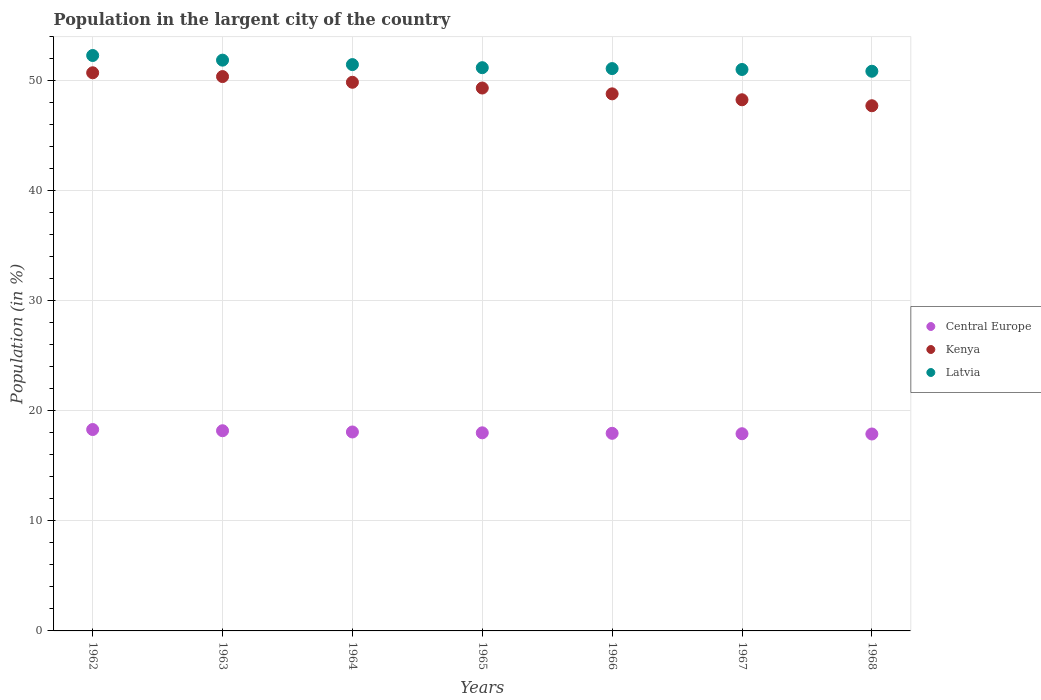Is the number of dotlines equal to the number of legend labels?
Provide a succinct answer. Yes. What is the percentage of population in the largent city in Latvia in 1965?
Provide a succinct answer. 51.19. Across all years, what is the maximum percentage of population in the largent city in Kenya?
Offer a terse response. 50.73. Across all years, what is the minimum percentage of population in the largent city in Central Europe?
Provide a short and direct response. 17.9. In which year was the percentage of population in the largent city in Latvia minimum?
Provide a succinct answer. 1968. What is the total percentage of population in the largent city in Latvia in the graph?
Give a very brief answer. 359.87. What is the difference between the percentage of population in the largent city in Kenya in 1965 and that in 1967?
Your answer should be compact. 1.07. What is the difference between the percentage of population in the largent city in Central Europe in 1962 and the percentage of population in the largent city in Kenya in 1963?
Your response must be concise. -32.08. What is the average percentage of population in the largent city in Latvia per year?
Make the answer very short. 51.41. In the year 1962, what is the difference between the percentage of population in the largent city in Latvia and percentage of population in the largent city in Kenya?
Your answer should be compact. 1.57. What is the ratio of the percentage of population in the largent city in Latvia in 1962 to that in 1964?
Keep it short and to the point. 1.02. Is the difference between the percentage of population in the largent city in Latvia in 1962 and 1963 greater than the difference between the percentage of population in the largent city in Kenya in 1962 and 1963?
Make the answer very short. Yes. What is the difference between the highest and the second highest percentage of population in the largent city in Central Europe?
Your answer should be very brief. 0.11. What is the difference between the highest and the lowest percentage of population in the largent city in Central Europe?
Provide a short and direct response. 0.41. In how many years, is the percentage of population in the largent city in Central Europe greater than the average percentage of population in the largent city in Central Europe taken over all years?
Your response must be concise. 3. Is it the case that in every year, the sum of the percentage of population in the largent city in Kenya and percentage of population in the largent city in Central Europe  is greater than the percentage of population in the largent city in Latvia?
Your answer should be very brief. Yes. Does the percentage of population in the largent city in Latvia monotonically increase over the years?
Offer a very short reply. No. Is the percentage of population in the largent city in Central Europe strictly less than the percentage of population in the largent city in Kenya over the years?
Ensure brevity in your answer.  Yes. How many years are there in the graph?
Provide a succinct answer. 7. Are the values on the major ticks of Y-axis written in scientific E-notation?
Provide a succinct answer. No. How are the legend labels stacked?
Give a very brief answer. Vertical. What is the title of the graph?
Ensure brevity in your answer.  Population in the largent city of the country. What is the Population (in %) of Central Europe in 1962?
Your answer should be compact. 18.31. What is the Population (in %) in Kenya in 1962?
Provide a succinct answer. 50.73. What is the Population (in %) in Latvia in 1962?
Ensure brevity in your answer.  52.3. What is the Population (in %) in Central Europe in 1963?
Ensure brevity in your answer.  18.2. What is the Population (in %) of Kenya in 1963?
Your answer should be very brief. 50.39. What is the Population (in %) of Latvia in 1963?
Your answer should be very brief. 51.88. What is the Population (in %) of Central Europe in 1964?
Offer a very short reply. 18.08. What is the Population (in %) in Kenya in 1964?
Keep it short and to the point. 49.87. What is the Population (in %) in Latvia in 1964?
Your answer should be very brief. 51.48. What is the Population (in %) of Central Europe in 1965?
Your answer should be very brief. 18.01. What is the Population (in %) in Kenya in 1965?
Your answer should be very brief. 49.35. What is the Population (in %) in Latvia in 1965?
Make the answer very short. 51.19. What is the Population (in %) in Central Europe in 1966?
Provide a short and direct response. 17.96. What is the Population (in %) in Kenya in 1966?
Ensure brevity in your answer.  48.82. What is the Population (in %) of Latvia in 1966?
Provide a succinct answer. 51.11. What is the Population (in %) of Central Europe in 1967?
Ensure brevity in your answer.  17.92. What is the Population (in %) in Kenya in 1967?
Your answer should be very brief. 48.28. What is the Population (in %) in Latvia in 1967?
Provide a short and direct response. 51.03. What is the Population (in %) in Central Europe in 1968?
Your answer should be compact. 17.9. What is the Population (in %) in Kenya in 1968?
Provide a short and direct response. 47.74. What is the Population (in %) of Latvia in 1968?
Your response must be concise. 50.87. Across all years, what is the maximum Population (in %) of Central Europe?
Your response must be concise. 18.31. Across all years, what is the maximum Population (in %) of Kenya?
Give a very brief answer. 50.73. Across all years, what is the maximum Population (in %) in Latvia?
Provide a short and direct response. 52.3. Across all years, what is the minimum Population (in %) of Central Europe?
Your response must be concise. 17.9. Across all years, what is the minimum Population (in %) in Kenya?
Offer a terse response. 47.74. Across all years, what is the minimum Population (in %) of Latvia?
Provide a succinct answer. 50.87. What is the total Population (in %) of Central Europe in the graph?
Offer a very short reply. 126.37. What is the total Population (in %) in Kenya in the graph?
Your answer should be compact. 345.16. What is the total Population (in %) in Latvia in the graph?
Give a very brief answer. 359.87. What is the difference between the Population (in %) of Central Europe in 1962 and that in 1963?
Keep it short and to the point. 0.11. What is the difference between the Population (in %) of Kenya in 1962 and that in 1963?
Give a very brief answer. 0.34. What is the difference between the Population (in %) in Latvia in 1962 and that in 1963?
Your response must be concise. 0.42. What is the difference between the Population (in %) of Central Europe in 1962 and that in 1964?
Offer a very short reply. 0.22. What is the difference between the Population (in %) in Kenya in 1962 and that in 1964?
Ensure brevity in your answer.  0.86. What is the difference between the Population (in %) in Latvia in 1962 and that in 1964?
Make the answer very short. 0.83. What is the difference between the Population (in %) in Central Europe in 1962 and that in 1965?
Your answer should be compact. 0.3. What is the difference between the Population (in %) in Kenya in 1962 and that in 1965?
Provide a short and direct response. 1.39. What is the difference between the Population (in %) in Latvia in 1962 and that in 1965?
Provide a succinct answer. 1.11. What is the difference between the Population (in %) of Central Europe in 1962 and that in 1966?
Make the answer very short. 0.34. What is the difference between the Population (in %) in Kenya in 1962 and that in 1966?
Offer a very short reply. 1.91. What is the difference between the Population (in %) of Latvia in 1962 and that in 1966?
Provide a succinct answer. 1.19. What is the difference between the Population (in %) of Central Europe in 1962 and that in 1967?
Your answer should be compact. 0.38. What is the difference between the Population (in %) in Kenya in 1962 and that in 1967?
Offer a terse response. 2.45. What is the difference between the Population (in %) of Latvia in 1962 and that in 1967?
Offer a terse response. 1.27. What is the difference between the Population (in %) of Central Europe in 1962 and that in 1968?
Your answer should be very brief. 0.41. What is the difference between the Population (in %) in Kenya in 1962 and that in 1968?
Offer a terse response. 3. What is the difference between the Population (in %) in Latvia in 1962 and that in 1968?
Make the answer very short. 1.43. What is the difference between the Population (in %) in Central Europe in 1963 and that in 1964?
Your answer should be compact. 0.11. What is the difference between the Population (in %) in Kenya in 1963 and that in 1964?
Keep it short and to the point. 0.52. What is the difference between the Population (in %) of Latvia in 1963 and that in 1964?
Provide a succinct answer. 0.4. What is the difference between the Population (in %) in Central Europe in 1963 and that in 1965?
Your answer should be very brief. 0.19. What is the difference between the Population (in %) in Kenya in 1963 and that in 1965?
Keep it short and to the point. 1.04. What is the difference between the Population (in %) in Latvia in 1963 and that in 1965?
Offer a terse response. 0.69. What is the difference between the Population (in %) in Central Europe in 1963 and that in 1966?
Your answer should be very brief. 0.23. What is the difference between the Population (in %) in Kenya in 1963 and that in 1966?
Your response must be concise. 1.57. What is the difference between the Population (in %) of Latvia in 1963 and that in 1966?
Provide a short and direct response. 0.77. What is the difference between the Population (in %) in Central Europe in 1963 and that in 1967?
Give a very brief answer. 0.27. What is the difference between the Population (in %) of Kenya in 1963 and that in 1967?
Offer a very short reply. 2.11. What is the difference between the Population (in %) in Latvia in 1963 and that in 1967?
Offer a terse response. 0.85. What is the difference between the Population (in %) of Central Europe in 1963 and that in 1968?
Keep it short and to the point. 0.3. What is the difference between the Population (in %) of Kenya in 1963 and that in 1968?
Offer a very short reply. 2.65. What is the difference between the Population (in %) in Latvia in 1963 and that in 1968?
Your answer should be compact. 1.01. What is the difference between the Population (in %) in Central Europe in 1964 and that in 1965?
Your answer should be compact. 0.08. What is the difference between the Population (in %) of Kenya in 1964 and that in 1965?
Your answer should be compact. 0.52. What is the difference between the Population (in %) in Latvia in 1964 and that in 1965?
Your answer should be compact. 0.28. What is the difference between the Population (in %) of Central Europe in 1964 and that in 1966?
Ensure brevity in your answer.  0.12. What is the difference between the Population (in %) of Kenya in 1964 and that in 1966?
Offer a terse response. 1.05. What is the difference between the Population (in %) in Latvia in 1964 and that in 1966?
Your answer should be very brief. 0.36. What is the difference between the Population (in %) of Central Europe in 1964 and that in 1967?
Offer a terse response. 0.16. What is the difference between the Population (in %) of Kenya in 1964 and that in 1967?
Keep it short and to the point. 1.59. What is the difference between the Population (in %) in Latvia in 1964 and that in 1967?
Offer a very short reply. 0.44. What is the difference between the Population (in %) in Central Europe in 1964 and that in 1968?
Your answer should be very brief. 0.18. What is the difference between the Population (in %) of Kenya in 1964 and that in 1968?
Make the answer very short. 2.13. What is the difference between the Population (in %) in Latvia in 1964 and that in 1968?
Provide a succinct answer. 0.6. What is the difference between the Population (in %) of Central Europe in 1965 and that in 1966?
Give a very brief answer. 0.05. What is the difference between the Population (in %) in Kenya in 1965 and that in 1966?
Your answer should be very brief. 0.53. What is the difference between the Population (in %) in Latvia in 1965 and that in 1966?
Offer a very short reply. 0.08. What is the difference between the Population (in %) in Central Europe in 1965 and that in 1967?
Provide a short and direct response. 0.08. What is the difference between the Population (in %) of Kenya in 1965 and that in 1967?
Provide a short and direct response. 1.07. What is the difference between the Population (in %) in Latvia in 1965 and that in 1967?
Offer a terse response. 0.16. What is the difference between the Population (in %) in Central Europe in 1965 and that in 1968?
Your response must be concise. 0.11. What is the difference between the Population (in %) of Kenya in 1965 and that in 1968?
Provide a short and direct response. 1.61. What is the difference between the Population (in %) in Latvia in 1965 and that in 1968?
Your answer should be compact. 0.32. What is the difference between the Population (in %) of Central Europe in 1966 and that in 1967?
Provide a short and direct response. 0.04. What is the difference between the Population (in %) of Kenya in 1966 and that in 1967?
Your answer should be compact. 0.54. What is the difference between the Population (in %) of Latvia in 1966 and that in 1967?
Offer a very short reply. 0.08. What is the difference between the Population (in %) of Central Europe in 1966 and that in 1968?
Your response must be concise. 0.06. What is the difference between the Population (in %) of Kenya in 1966 and that in 1968?
Your answer should be very brief. 1.08. What is the difference between the Population (in %) of Latvia in 1966 and that in 1968?
Ensure brevity in your answer.  0.24. What is the difference between the Population (in %) of Central Europe in 1967 and that in 1968?
Offer a very short reply. 0.02. What is the difference between the Population (in %) in Kenya in 1967 and that in 1968?
Offer a very short reply. 0.54. What is the difference between the Population (in %) of Latvia in 1967 and that in 1968?
Offer a terse response. 0.16. What is the difference between the Population (in %) of Central Europe in 1962 and the Population (in %) of Kenya in 1963?
Offer a terse response. -32.08. What is the difference between the Population (in %) of Central Europe in 1962 and the Population (in %) of Latvia in 1963?
Provide a succinct answer. -33.57. What is the difference between the Population (in %) in Kenya in 1962 and the Population (in %) in Latvia in 1963?
Your answer should be compact. -1.15. What is the difference between the Population (in %) of Central Europe in 1962 and the Population (in %) of Kenya in 1964?
Provide a succinct answer. -31.56. What is the difference between the Population (in %) of Central Europe in 1962 and the Population (in %) of Latvia in 1964?
Ensure brevity in your answer.  -33.17. What is the difference between the Population (in %) of Kenya in 1962 and the Population (in %) of Latvia in 1964?
Give a very brief answer. -0.74. What is the difference between the Population (in %) in Central Europe in 1962 and the Population (in %) in Kenya in 1965?
Your answer should be very brief. -31.04. What is the difference between the Population (in %) in Central Europe in 1962 and the Population (in %) in Latvia in 1965?
Your answer should be very brief. -32.89. What is the difference between the Population (in %) in Kenya in 1962 and the Population (in %) in Latvia in 1965?
Your answer should be compact. -0.46. What is the difference between the Population (in %) of Central Europe in 1962 and the Population (in %) of Kenya in 1966?
Provide a succinct answer. -30.51. What is the difference between the Population (in %) in Central Europe in 1962 and the Population (in %) in Latvia in 1966?
Make the answer very short. -32.81. What is the difference between the Population (in %) of Kenya in 1962 and the Population (in %) of Latvia in 1966?
Give a very brief answer. -0.38. What is the difference between the Population (in %) of Central Europe in 1962 and the Population (in %) of Kenya in 1967?
Make the answer very short. -29.97. What is the difference between the Population (in %) in Central Europe in 1962 and the Population (in %) in Latvia in 1967?
Provide a succinct answer. -32.73. What is the difference between the Population (in %) in Kenya in 1962 and the Population (in %) in Latvia in 1967?
Keep it short and to the point. -0.3. What is the difference between the Population (in %) in Central Europe in 1962 and the Population (in %) in Kenya in 1968?
Give a very brief answer. -29.43. What is the difference between the Population (in %) of Central Europe in 1962 and the Population (in %) of Latvia in 1968?
Your response must be concise. -32.57. What is the difference between the Population (in %) in Kenya in 1962 and the Population (in %) in Latvia in 1968?
Offer a terse response. -0.14. What is the difference between the Population (in %) in Central Europe in 1963 and the Population (in %) in Kenya in 1964?
Your answer should be compact. -31.67. What is the difference between the Population (in %) in Central Europe in 1963 and the Population (in %) in Latvia in 1964?
Provide a succinct answer. -33.28. What is the difference between the Population (in %) of Kenya in 1963 and the Population (in %) of Latvia in 1964?
Make the answer very short. -1.09. What is the difference between the Population (in %) of Central Europe in 1963 and the Population (in %) of Kenya in 1965?
Make the answer very short. -31.15. What is the difference between the Population (in %) of Central Europe in 1963 and the Population (in %) of Latvia in 1965?
Keep it short and to the point. -33. What is the difference between the Population (in %) in Kenya in 1963 and the Population (in %) in Latvia in 1965?
Your answer should be very brief. -0.81. What is the difference between the Population (in %) of Central Europe in 1963 and the Population (in %) of Kenya in 1966?
Your answer should be compact. -30.62. What is the difference between the Population (in %) of Central Europe in 1963 and the Population (in %) of Latvia in 1966?
Provide a short and direct response. -32.92. What is the difference between the Population (in %) in Kenya in 1963 and the Population (in %) in Latvia in 1966?
Your answer should be very brief. -0.73. What is the difference between the Population (in %) in Central Europe in 1963 and the Population (in %) in Kenya in 1967?
Provide a short and direct response. -30.08. What is the difference between the Population (in %) in Central Europe in 1963 and the Population (in %) in Latvia in 1967?
Offer a terse response. -32.84. What is the difference between the Population (in %) of Kenya in 1963 and the Population (in %) of Latvia in 1967?
Provide a short and direct response. -0.64. What is the difference between the Population (in %) in Central Europe in 1963 and the Population (in %) in Kenya in 1968?
Provide a succinct answer. -29.54. What is the difference between the Population (in %) in Central Europe in 1963 and the Population (in %) in Latvia in 1968?
Make the answer very short. -32.67. What is the difference between the Population (in %) in Kenya in 1963 and the Population (in %) in Latvia in 1968?
Offer a very short reply. -0.48. What is the difference between the Population (in %) in Central Europe in 1964 and the Population (in %) in Kenya in 1965?
Offer a very short reply. -31.26. What is the difference between the Population (in %) of Central Europe in 1964 and the Population (in %) of Latvia in 1965?
Your response must be concise. -33.11. What is the difference between the Population (in %) in Kenya in 1964 and the Population (in %) in Latvia in 1965?
Ensure brevity in your answer.  -1.33. What is the difference between the Population (in %) of Central Europe in 1964 and the Population (in %) of Kenya in 1966?
Offer a terse response. -30.73. What is the difference between the Population (in %) in Central Europe in 1964 and the Population (in %) in Latvia in 1966?
Offer a very short reply. -33.03. What is the difference between the Population (in %) in Kenya in 1964 and the Population (in %) in Latvia in 1966?
Provide a short and direct response. -1.24. What is the difference between the Population (in %) in Central Europe in 1964 and the Population (in %) in Kenya in 1967?
Your response must be concise. -30.2. What is the difference between the Population (in %) of Central Europe in 1964 and the Population (in %) of Latvia in 1967?
Ensure brevity in your answer.  -32.95. What is the difference between the Population (in %) in Kenya in 1964 and the Population (in %) in Latvia in 1967?
Keep it short and to the point. -1.16. What is the difference between the Population (in %) in Central Europe in 1964 and the Population (in %) in Kenya in 1968?
Make the answer very short. -29.65. What is the difference between the Population (in %) of Central Europe in 1964 and the Population (in %) of Latvia in 1968?
Provide a succinct answer. -32.79. What is the difference between the Population (in %) of Kenya in 1964 and the Population (in %) of Latvia in 1968?
Ensure brevity in your answer.  -1. What is the difference between the Population (in %) of Central Europe in 1965 and the Population (in %) of Kenya in 1966?
Offer a terse response. -30.81. What is the difference between the Population (in %) of Central Europe in 1965 and the Population (in %) of Latvia in 1966?
Your answer should be compact. -33.11. What is the difference between the Population (in %) in Kenya in 1965 and the Population (in %) in Latvia in 1966?
Offer a very short reply. -1.77. What is the difference between the Population (in %) in Central Europe in 1965 and the Population (in %) in Kenya in 1967?
Your answer should be very brief. -30.27. What is the difference between the Population (in %) of Central Europe in 1965 and the Population (in %) of Latvia in 1967?
Keep it short and to the point. -33.02. What is the difference between the Population (in %) of Kenya in 1965 and the Population (in %) of Latvia in 1967?
Give a very brief answer. -1.69. What is the difference between the Population (in %) in Central Europe in 1965 and the Population (in %) in Kenya in 1968?
Offer a very short reply. -29.73. What is the difference between the Population (in %) of Central Europe in 1965 and the Population (in %) of Latvia in 1968?
Ensure brevity in your answer.  -32.86. What is the difference between the Population (in %) in Kenya in 1965 and the Population (in %) in Latvia in 1968?
Your answer should be compact. -1.52. What is the difference between the Population (in %) of Central Europe in 1966 and the Population (in %) of Kenya in 1967?
Offer a terse response. -30.32. What is the difference between the Population (in %) in Central Europe in 1966 and the Population (in %) in Latvia in 1967?
Provide a succinct answer. -33.07. What is the difference between the Population (in %) of Kenya in 1966 and the Population (in %) of Latvia in 1967?
Offer a terse response. -2.21. What is the difference between the Population (in %) in Central Europe in 1966 and the Population (in %) in Kenya in 1968?
Provide a succinct answer. -29.77. What is the difference between the Population (in %) in Central Europe in 1966 and the Population (in %) in Latvia in 1968?
Keep it short and to the point. -32.91. What is the difference between the Population (in %) of Kenya in 1966 and the Population (in %) of Latvia in 1968?
Ensure brevity in your answer.  -2.05. What is the difference between the Population (in %) in Central Europe in 1967 and the Population (in %) in Kenya in 1968?
Your response must be concise. -29.81. What is the difference between the Population (in %) in Central Europe in 1967 and the Population (in %) in Latvia in 1968?
Offer a terse response. -32.95. What is the difference between the Population (in %) of Kenya in 1967 and the Population (in %) of Latvia in 1968?
Give a very brief answer. -2.59. What is the average Population (in %) in Central Europe per year?
Provide a succinct answer. 18.05. What is the average Population (in %) in Kenya per year?
Keep it short and to the point. 49.31. What is the average Population (in %) of Latvia per year?
Your response must be concise. 51.41. In the year 1962, what is the difference between the Population (in %) in Central Europe and Population (in %) in Kenya?
Your response must be concise. -32.43. In the year 1962, what is the difference between the Population (in %) of Central Europe and Population (in %) of Latvia?
Your answer should be compact. -34. In the year 1962, what is the difference between the Population (in %) in Kenya and Population (in %) in Latvia?
Your answer should be very brief. -1.57. In the year 1963, what is the difference between the Population (in %) of Central Europe and Population (in %) of Kenya?
Offer a very short reply. -32.19. In the year 1963, what is the difference between the Population (in %) of Central Europe and Population (in %) of Latvia?
Offer a terse response. -33.68. In the year 1963, what is the difference between the Population (in %) in Kenya and Population (in %) in Latvia?
Keep it short and to the point. -1.49. In the year 1964, what is the difference between the Population (in %) in Central Europe and Population (in %) in Kenya?
Keep it short and to the point. -31.79. In the year 1964, what is the difference between the Population (in %) in Central Europe and Population (in %) in Latvia?
Make the answer very short. -33.39. In the year 1964, what is the difference between the Population (in %) in Kenya and Population (in %) in Latvia?
Your response must be concise. -1.61. In the year 1965, what is the difference between the Population (in %) of Central Europe and Population (in %) of Kenya?
Make the answer very short. -31.34. In the year 1965, what is the difference between the Population (in %) in Central Europe and Population (in %) in Latvia?
Give a very brief answer. -33.19. In the year 1965, what is the difference between the Population (in %) of Kenya and Population (in %) of Latvia?
Provide a succinct answer. -1.85. In the year 1966, what is the difference between the Population (in %) of Central Europe and Population (in %) of Kenya?
Your response must be concise. -30.86. In the year 1966, what is the difference between the Population (in %) in Central Europe and Population (in %) in Latvia?
Offer a terse response. -33.15. In the year 1966, what is the difference between the Population (in %) in Kenya and Population (in %) in Latvia?
Your answer should be compact. -2.3. In the year 1967, what is the difference between the Population (in %) in Central Europe and Population (in %) in Kenya?
Keep it short and to the point. -30.35. In the year 1967, what is the difference between the Population (in %) in Central Europe and Population (in %) in Latvia?
Your response must be concise. -33.11. In the year 1967, what is the difference between the Population (in %) in Kenya and Population (in %) in Latvia?
Provide a short and direct response. -2.75. In the year 1968, what is the difference between the Population (in %) in Central Europe and Population (in %) in Kenya?
Your answer should be very brief. -29.84. In the year 1968, what is the difference between the Population (in %) of Central Europe and Population (in %) of Latvia?
Provide a short and direct response. -32.97. In the year 1968, what is the difference between the Population (in %) in Kenya and Population (in %) in Latvia?
Ensure brevity in your answer.  -3.13. What is the ratio of the Population (in %) in Kenya in 1962 to that in 1963?
Make the answer very short. 1.01. What is the ratio of the Population (in %) of Central Europe in 1962 to that in 1964?
Keep it short and to the point. 1.01. What is the ratio of the Population (in %) in Kenya in 1962 to that in 1964?
Offer a terse response. 1.02. What is the ratio of the Population (in %) of Latvia in 1962 to that in 1964?
Keep it short and to the point. 1.02. What is the ratio of the Population (in %) of Central Europe in 1962 to that in 1965?
Provide a short and direct response. 1.02. What is the ratio of the Population (in %) of Kenya in 1962 to that in 1965?
Offer a very short reply. 1.03. What is the ratio of the Population (in %) in Latvia in 1962 to that in 1965?
Offer a terse response. 1.02. What is the ratio of the Population (in %) in Central Europe in 1962 to that in 1966?
Your response must be concise. 1.02. What is the ratio of the Population (in %) in Kenya in 1962 to that in 1966?
Your response must be concise. 1.04. What is the ratio of the Population (in %) of Latvia in 1962 to that in 1966?
Give a very brief answer. 1.02. What is the ratio of the Population (in %) in Central Europe in 1962 to that in 1967?
Ensure brevity in your answer.  1.02. What is the ratio of the Population (in %) in Kenya in 1962 to that in 1967?
Give a very brief answer. 1.05. What is the ratio of the Population (in %) of Latvia in 1962 to that in 1967?
Provide a succinct answer. 1.02. What is the ratio of the Population (in %) in Central Europe in 1962 to that in 1968?
Offer a very short reply. 1.02. What is the ratio of the Population (in %) of Kenya in 1962 to that in 1968?
Make the answer very short. 1.06. What is the ratio of the Population (in %) in Latvia in 1962 to that in 1968?
Give a very brief answer. 1.03. What is the ratio of the Population (in %) in Central Europe in 1963 to that in 1964?
Your answer should be compact. 1.01. What is the ratio of the Population (in %) in Kenya in 1963 to that in 1964?
Your answer should be very brief. 1.01. What is the ratio of the Population (in %) of Latvia in 1963 to that in 1964?
Your response must be concise. 1.01. What is the ratio of the Population (in %) of Central Europe in 1963 to that in 1965?
Keep it short and to the point. 1.01. What is the ratio of the Population (in %) in Kenya in 1963 to that in 1965?
Make the answer very short. 1.02. What is the ratio of the Population (in %) of Latvia in 1963 to that in 1965?
Your response must be concise. 1.01. What is the ratio of the Population (in %) in Central Europe in 1963 to that in 1966?
Your answer should be compact. 1.01. What is the ratio of the Population (in %) of Kenya in 1963 to that in 1966?
Give a very brief answer. 1.03. What is the ratio of the Population (in %) in Latvia in 1963 to that in 1966?
Make the answer very short. 1.01. What is the ratio of the Population (in %) of Central Europe in 1963 to that in 1967?
Your answer should be very brief. 1.02. What is the ratio of the Population (in %) in Kenya in 1963 to that in 1967?
Provide a succinct answer. 1.04. What is the ratio of the Population (in %) of Latvia in 1963 to that in 1967?
Your answer should be very brief. 1.02. What is the ratio of the Population (in %) in Central Europe in 1963 to that in 1968?
Offer a very short reply. 1.02. What is the ratio of the Population (in %) of Kenya in 1963 to that in 1968?
Ensure brevity in your answer.  1.06. What is the ratio of the Population (in %) of Latvia in 1963 to that in 1968?
Provide a succinct answer. 1.02. What is the ratio of the Population (in %) of Central Europe in 1964 to that in 1965?
Your response must be concise. 1. What is the ratio of the Population (in %) of Kenya in 1964 to that in 1965?
Make the answer very short. 1.01. What is the ratio of the Population (in %) in Central Europe in 1964 to that in 1966?
Your answer should be compact. 1.01. What is the ratio of the Population (in %) of Kenya in 1964 to that in 1966?
Your answer should be compact. 1.02. What is the ratio of the Population (in %) in Latvia in 1964 to that in 1966?
Your answer should be compact. 1.01. What is the ratio of the Population (in %) in Central Europe in 1964 to that in 1967?
Give a very brief answer. 1.01. What is the ratio of the Population (in %) of Kenya in 1964 to that in 1967?
Offer a very short reply. 1.03. What is the ratio of the Population (in %) of Latvia in 1964 to that in 1967?
Your answer should be very brief. 1.01. What is the ratio of the Population (in %) in Central Europe in 1964 to that in 1968?
Offer a terse response. 1.01. What is the ratio of the Population (in %) in Kenya in 1964 to that in 1968?
Keep it short and to the point. 1.04. What is the ratio of the Population (in %) of Latvia in 1964 to that in 1968?
Your answer should be compact. 1.01. What is the ratio of the Population (in %) of Central Europe in 1965 to that in 1966?
Your answer should be very brief. 1. What is the ratio of the Population (in %) of Kenya in 1965 to that in 1966?
Your answer should be compact. 1.01. What is the ratio of the Population (in %) in Latvia in 1965 to that in 1966?
Give a very brief answer. 1. What is the ratio of the Population (in %) in Kenya in 1965 to that in 1967?
Give a very brief answer. 1.02. What is the ratio of the Population (in %) of Central Europe in 1965 to that in 1968?
Provide a short and direct response. 1.01. What is the ratio of the Population (in %) of Kenya in 1965 to that in 1968?
Give a very brief answer. 1.03. What is the ratio of the Population (in %) in Latvia in 1965 to that in 1968?
Your answer should be compact. 1.01. What is the ratio of the Population (in %) of Central Europe in 1966 to that in 1967?
Your answer should be compact. 1. What is the ratio of the Population (in %) in Kenya in 1966 to that in 1967?
Make the answer very short. 1.01. What is the ratio of the Population (in %) in Latvia in 1966 to that in 1967?
Your answer should be compact. 1. What is the ratio of the Population (in %) in Central Europe in 1966 to that in 1968?
Your answer should be compact. 1. What is the ratio of the Population (in %) of Kenya in 1966 to that in 1968?
Your response must be concise. 1.02. What is the ratio of the Population (in %) of Latvia in 1966 to that in 1968?
Offer a very short reply. 1. What is the ratio of the Population (in %) in Kenya in 1967 to that in 1968?
Offer a very short reply. 1.01. What is the ratio of the Population (in %) in Latvia in 1967 to that in 1968?
Give a very brief answer. 1. What is the difference between the highest and the second highest Population (in %) of Central Europe?
Give a very brief answer. 0.11. What is the difference between the highest and the second highest Population (in %) of Kenya?
Offer a very short reply. 0.34. What is the difference between the highest and the second highest Population (in %) of Latvia?
Your response must be concise. 0.42. What is the difference between the highest and the lowest Population (in %) of Central Europe?
Offer a terse response. 0.41. What is the difference between the highest and the lowest Population (in %) of Kenya?
Your answer should be very brief. 3. What is the difference between the highest and the lowest Population (in %) of Latvia?
Offer a very short reply. 1.43. 